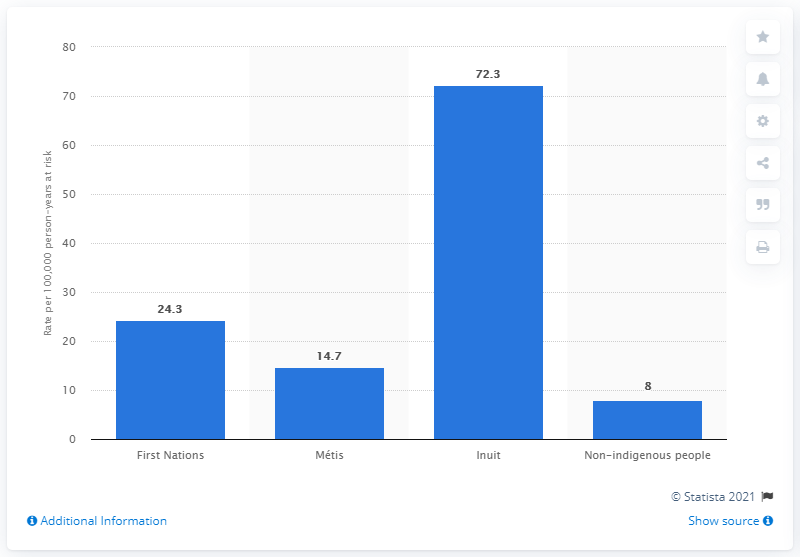Point out several critical features in this image. The suicide rate among Inuit people in Canada was 72.3 per 100,000 population from 2011 to 2016. 